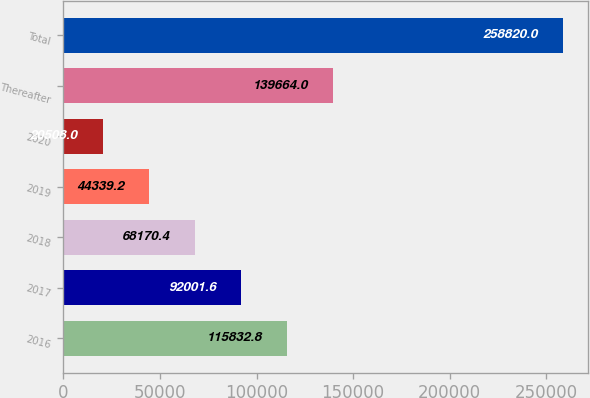<chart> <loc_0><loc_0><loc_500><loc_500><bar_chart><fcel>2016<fcel>2017<fcel>2018<fcel>2019<fcel>2020<fcel>Thereafter<fcel>Total<nl><fcel>115833<fcel>92001.6<fcel>68170.4<fcel>44339.2<fcel>20508<fcel>139664<fcel>258820<nl></chart> 